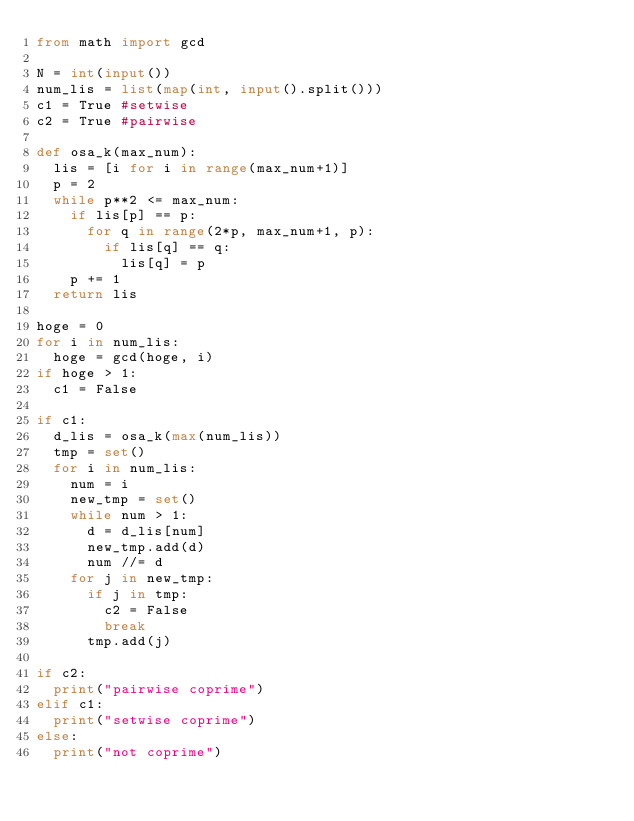Convert code to text. <code><loc_0><loc_0><loc_500><loc_500><_Python_>from math import gcd

N = int(input())
num_lis = list(map(int, input().split()))
c1 = True #setwise
c2 = True #pairwise

def osa_k(max_num):
  lis = [i for i in range(max_num+1)]
  p = 2
  while p**2 <= max_num:
    if lis[p] == p:
      for q in range(2*p, max_num+1, p):
        if lis[q] == q:
          lis[q] = p
    p += 1
  return lis

hoge = 0
for i in num_lis:
  hoge = gcd(hoge, i)
if hoge > 1:
  c1 = False

if c1:
  d_lis = osa_k(max(num_lis))
  tmp = set()
  for i in num_lis:
    num = i
    new_tmp = set()
    while num > 1:
      d = d_lis[num]
      new_tmp.add(d)
      num //= d
    for j in new_tmp:
      if j in tmp:
        c2 = False
        break
      tmp.add(j)

if c2:
  print("pairwise coprime")
elif c1:
  print("setwise coprime")
else:
  print("not coprime")</code> 